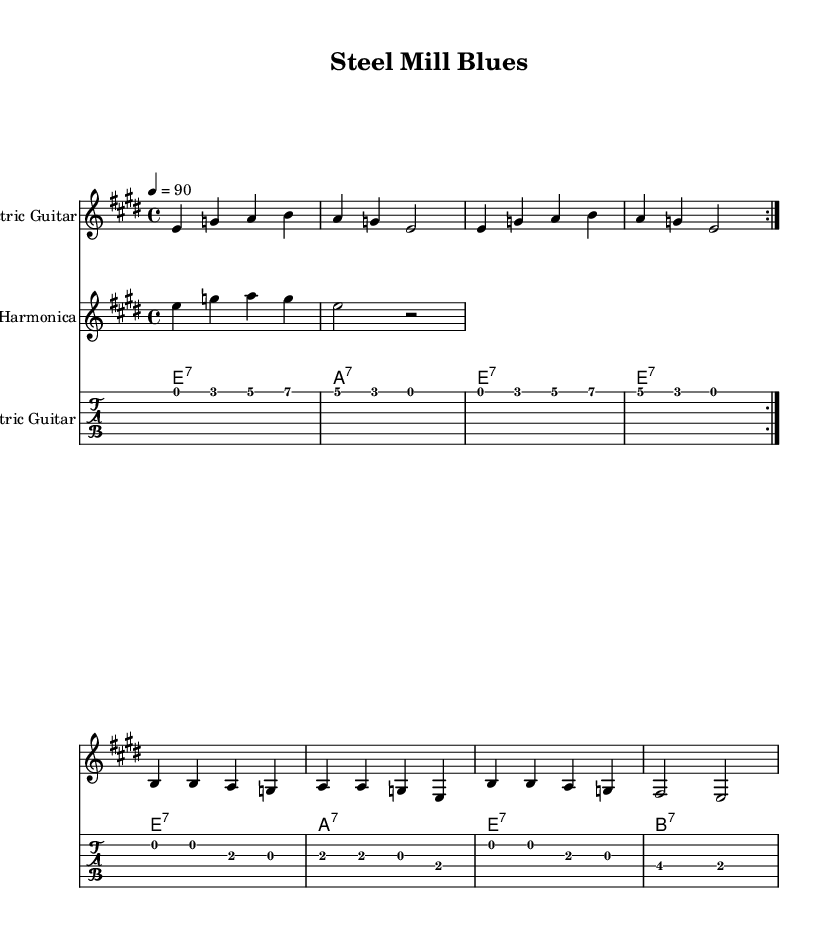What is the key signature of this music? The key signature is E major, which has four sharps (F#, C#, G#, and D#). This can be identified by looking at the key signature section located at the beginning of the staff.
Answer: E major What is the time signature of this music? The time signature is 4/4, which indicates four beats per measure and that the quarter note gets one beat. This can be determined from the notation at the beginning of the staff.
Answer: 4/4 What is the tempo marking of this piece? The tempo marking indicates a speed of quarter note equals 90 beats per minute, which suggests a moderate pace. This is indicated by the "4 = 90" notation seen at the start of the score.
Answer: 90 How many measures are there in the guitar verse before it repeats? The guitar verse contains four measures before it repeats, as indicated by the division of the music into distinct measures, and the instruction to repeat after the second iteration.
Answer: 4 What chords are used in the chorus section? The chords used in the chorus are B7, A7, and E7, followed by B7. This can be deduced from the chord symbols placed above the staff during the chorus section of the score.
Answer: B7, A7, E7 Why is the electric guitar prominent in this blues score? The electric guitar is a key instrument in blues music, often providing the primary melodic elements, including riffs and solos typical of the genre. It is the first instrument mentioned and has the most significant presence in the music.
Answer: Electric guitar 